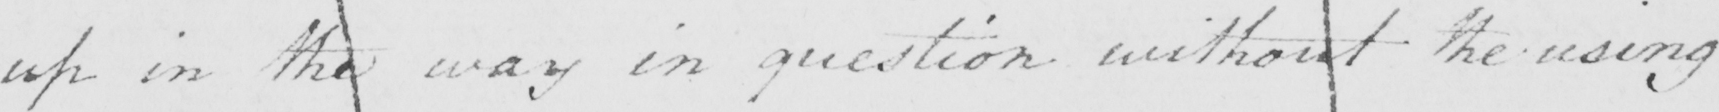Can you tell me what this handwritten text says? up in the way in question without the using 